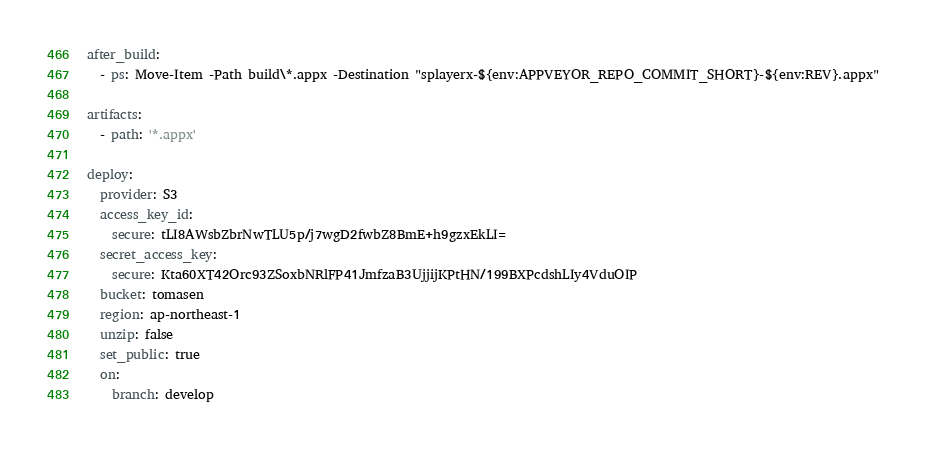<code> <loc_0><loc_0><loc_500><loc_500><_YAML_>after_build:
  - ps: Move-Item -Path build\*.appx -Destination "splayerx-${env:APPVEYOR_REPO_COMMIT_SHORT}-${env:REV}.appx"

artifacts:
  - path: '*.appx'

deploy:
  provider: S3
  access_key_id:
    secure: tLI8AWsbZbrNwTLU5p/j7wgD2fwbZ8BmE+h9gzxEkLI=
  secret_access_key:
    secure: Kta60XT42Orc93ZSoxbNRlFP41JmfzaB3UjjijKPtHN/199BXPcdshLIy4VduOIP
  bucket: tomasen
  region: ap-northeast-1
  unzip: false
  set_public: true
  on:
    branch: develop
</code> 